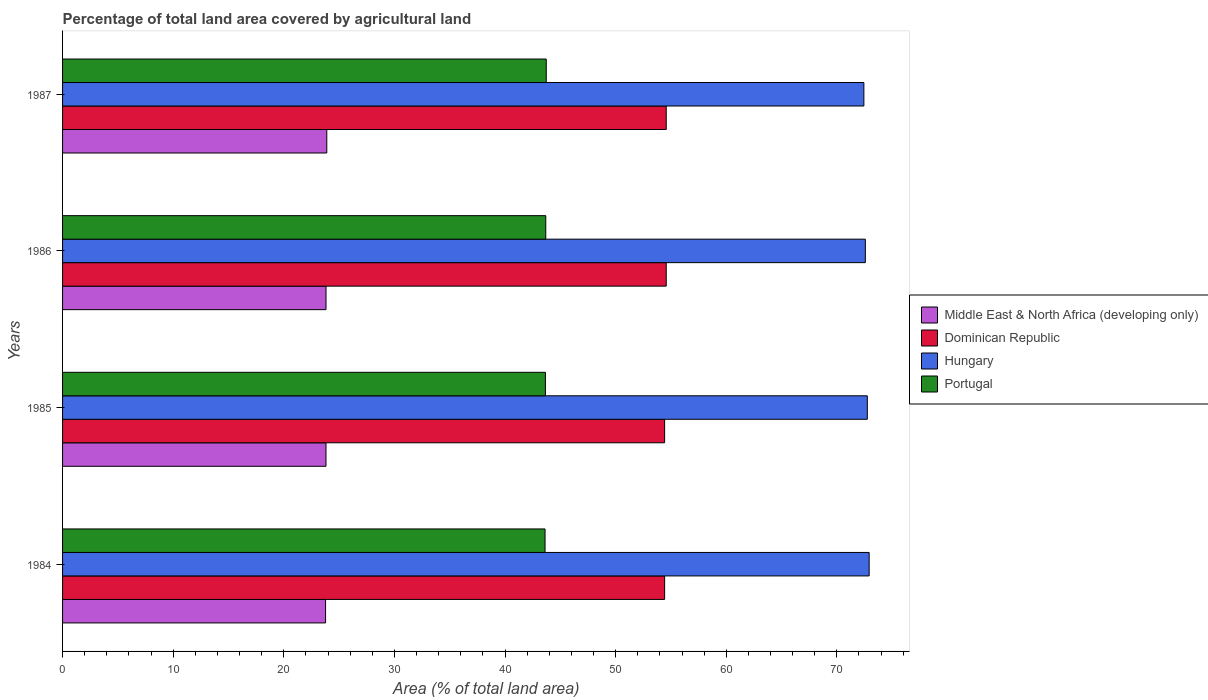How many different coloured bars are there?
Provide a short and direct response. 4. How many groups of bars are there?
Offer a terse response. 4. Are the number of bars on each tick of the Y-axis equal?
Give a very brief answer. Yes. What is the label of the 3rd group of bars from the top?
Provide a short and direct response. 1985. What is the percentage of agricultural land in Portugal in 1986?
Make the answer very short. 43.68. Across all years, what is the maximum percentage of agricultural land in Dominican Republic?
Ensure brevity in your answer.  54.57. Across all years, what is the minimum percentage of agricultural land in Hungary?
Keep it short and to the point. 72.44. What is the total percentage of agricultural land in Hungary in the graph?
Offer a terse response. 290.69. What is the difference between the percentage of agricultural land in Portugal in 1984 and that in 1985?
Provide a short and direct response. -0.03. What is the difference between the percentage of agricultural land in Dominican Republic in 1987 and the percentage of agricultural land in Portugal in 1985?
Your answer should be compact. 10.92. What is the average percentage of agricultural land in Dominican Republic per year?
Your answer should be very brief. 54.5. In the year 1984, what is the difference between the percentage of agricultural land in Portugal and percentage of agricultural land in Hungary?
Offer a very short reply. -29.3. What is the ratio of the percentage of agricultural land in Middle East & North Africa (developing only) in 1984 to that in 1986?
Give a very brief answer. 1. What is the difference between the highest and the second highest percentage of agricultural land in Middle East & North Africa (developing only)?
Give a very brief answer. 0.07. What is the difference between the highest and the lowest percentage of agricultural land in Middle East & North Africa (developing only)?
Your answer should be compact. 0.11. Is the sum of the percentage of agricultural land in Middle East & North Africa (developing only) in 1986 and 1987 greater than the maximum percentage of agricultural land in Hungary across all years?
Keep it short and to the point. No. How many bars are there?
Keep it short and to the point. 16. Are all the bars in the graph horizontal?
Give a very brief answer. Yes. How many years are there in the graph?
Ensure brevity in your answer.  4. What is the difference between two consecutive major ticks on the X-axis?
Ensure brevity in your answer.  10. Does the graph contain grids?
Offer a terse response. No. How are the legend labels stacked?
Keep it short and to the point. Vertical. What is the title of the graph?
Offer a very short reply. Percentage of total land area covered by agricultural land. What is the label or title of the X-axis?
Provide a succinct answer. Area (% of total land area). What is the Area (% of total land area) in Middle East & North Africa (developing only) in 1984?
Make the answer very short. 23.78. What is the Area (% of total land area) of Dominican Republic in 1984?
Provide a short and direct response. 54.43. What is the Area (% of total land area) of Hungary in 1984?
Offer a terse response. 72.92. What is the Area (% of total land area) of Portugal in 1984?
Make the answer very short. 43.62. What is the Area (% of total land area) in Middle East & North Africa (developing only) in 1985?
Offer a very short reply. 23.81. What is the Area (% of total land area) of Dominican Republic in 1985?
Offer a very short reply. 54.43. What is the Area (% of total land area) of Hungary in 1985?
Provide a succinct answer. 72.75. What is the Area (% of total land area) in Portugal in 1985?
Your response must be concise. 43.65. What is the Area (% of total land area) in Middle East & North Africa (developing only) in 1986?
Make the answer very short. 23.82. What is the Area (% of total land area) of Dominican Republic in 1986?
Keep it short and to the point. 54.57. What is the Area (% of total land area) in Hungary in 1986?
Offer a very short reply. 72.57. What is the Area (% of total land area) in Portugal in 1986?
Provide a short and direct response. 43.68. What is the Area (% of total land area) of Middle East & North Africa (developing only) in 1987?
Your response must be concise. 23.89. What is the Area (% of total land area) of Dominican Republic in 1987?
Provide a short and direct response. 54.57. What is the Area (% of total land area) in Hungary in 1987?
Provide a succinct answer. 72.44. What is the Area (% of total land area) of Portugal in 1987?
Ensure brevity in your answer.  43.73. Across all years, what is the maximum Area (% of total land area) of Middle East & North Africa (developing only)?
Keep it short and to the point. 23.89. Across all years, what is the maximum Area (% of total land area) in Dominican Republic?
Provide a short and direct response. 54.57. Across all years, what is the maximum Area (% of total land area) of Hungary?
Offer a very short reply. 72.92. Across all years, what is the maximum Area (% of total land area) of Portugal?
Your answer should be compact. 43.73. Across all years, what is the minimum Area (% of total land area) of Middle East & North Africa (developing only)?
Offer a terse response. 23.78. Across all years, what is the minimum Area (% of total land area) in Dominican Republic?
Offer a terse response. 54.43. Across all years, what is the minimum Area (% of total land area) in Hungary?
Make the answer very short. 72.44. Across all years, what is the minimum Area (% of total land area) in Portugal?
Your answer should be very brief. 43.62. What is the total Area (% of total land area) of Middle East & North Africa (developing only) in the graph?
Make the answer very short. 95.3. What is the total Area (% of total land area) in Dominican Republic in the graph?
Your answer should be very brief. 218. What is the total Area (% of total land area) in Hungary in the graph?
Give a very brief answer. 290.69. What is the total Area (% of total land area) of Portugal in the graph?
Ensure brevity in your answer.  174.68. What is the difference between the Area (% of total land area) in Middle East & North Africa (developing only) in 1984 and that in 1985?
Keep it short and to the point. -0.04. What is the difference between the Area (% of total land area) in Dominican Republic in 1984 and that in 1985?
Your answer should be very brief. 0. What is the difference between the Area (% of total land area) of Hungary in 1984 and that in 1985?
Give a very brief answer. 0.17. What is the difference between the Area (% of total land area) in Portugal in 1984 and that in 1985?
Provide a succinct answer. -0.03. What is the difference between the Area (% of total land area) in Middle East & North Africa (developing only) in 1984 and that in 1986?
Your answer should be very brief. -0.04. What is the difference between the Area (% of total land area) of Dominican Republic in 1984 and that in 1986?
Offer a terse response. -0.14. What is the difference between the Area (% of total land area) of Hungary in 1984 and that in 1986?
Your response must be concise. 0.34. What is the difference between the Area (% of total land area) in Portugal in 1984 and that in 1986?
Keep it short and to the point. -0.07. What is the difference between the Area (% of total land area) of Middle East & North Africa (developing only) in 1984 and that in 1987?
Provide a short and direct response. -0.11. What is the difference between the Area (% of total land area) in Dominican Republic in 1984 and that in 1987?
Ensure brevity in your answer.  -0.14. What is the difference between the Area (% of total land area) in Hungary in 1984 and that in 1987?
Provide a short and direct response. 0.48. What is the difference between the Area (% of total land area) in Portugal in 1984 and that in 1987?
Offer a very short reply. -0.11. What is the difference between the Area (% of total land area) in Middle East & North Africa (developing only) in 1985 and that in 1986?
Your response must be concise. -0. What is the difference between the Area (% of total land area) of Dominican Republic in 1985 and that in 1986?
Your answer should be compact. -0.14. What is the difference between the Area (% of total land area) in Hungary in 1985 and that in 1986?
Provide a succinct answer. 0.18. What is the difference between the Area (% of total land area) of Portugal in 1985 and that in 1986?
Make the answer very short. -0.03. What is the difference between the Area (% of total land area) of Middle East & North Africa (developing only) in 1985 and that in 1987?
Your response must be concise. -0.07. What is the difference between the Area (% of total land area) of Dominican Republic in 1985 and that in 1987?
Your response must be concise. -0.14. What is the difference between the Area (% of total land area) in Hungary in 1985 and that in 1987?
Provide a succinct answer. 0.31. What is the difference between the Area (% of total land area) in Portugal in 1985 and that in 1987?
Keep it short and to the point. -0.08. What is the difference between the Area (% of total land area) of Middle East & North Africa (developing only) in 1986 and that in 1987?
Provide a short and direct response. -0.07. What is the difference between the Area (% of total land area) of Dominican Republic in 1986 and that in 1987?
Ensure brevity in your answer.  0. What is the difference between the Area (% of total land area) in Hungary in 1986 and that in 1987?
Offer a very short reply. 0.13. What is the difference between the Area (% of total land area) of Portugal in 1986 and that in 1987?
Your response must be concise. -0.04. What is the difference between the Area (% of total land area) in Middle East & North Africa (developing only) in 1984 and the Area (% of total land area) in Dominican Republic in 1985?
Ensure brevity in your answer.  -30.65. What is the difference between the Area (% of total land area) in Middle East & North Africa (developing only) in 1984 and the Area (% of total land area) in Hungary in 1985?
Your response must be concise. -48.98. What is the difference between the Area (% of total land area) in Middle East & North Africa (developing only) in 1984 and the Area (% of total land area) in Portugal in 1985?
Offer a very short reply. -19.87. What is the difference between the Area (% of total land area) of Dominican Republic in 1984 and the Area (% of total land area) of Hungary in 1985?
Provide a succinct answer. -18.32. What is the difference between the Area (% of total land area) in Dominican Republic in 1984 and the Area (% of total land area) in Portugal in 1985?
Offer a terse response. 10.78. What is the difference between the Area (% of total land area) in Hungary in 1984 and the Area (% of total land area) in Portugal in 1985?
Keep it short and to the point. 29.27. What is the difference between the Area (% of total land area) in Middle East & North Africa (developing only) in 1984 and the Area (% of total land area) in Dominican Republic in 1986?
Keep it short and to the point. -30.8. What is the difference between the Area (% of total land area) of Middle East & North Africa (developing only) in 1984 and the Area (% of total land area) of Hungary in 1986?
Give a very brief answer. -48.8. What is the difference between the Area (% of total land area) of Middle East & North Africa (developing only) in 1984 and the Area (% of total land area) of Portugal in 1986?
Offer a terse response. -19.91. What is the difference between the Area (% of total land area) in Dominican Republic in 1984 and the Area (% of total land area) in Hungary in 1986?
Provide a short and direct response. -18.15. What is the difference between the Area (% of total land area) in Dominican Republic in 1984 and the Area (% of total land area) in Portugal in 1986?
Ensure brevity in your answer.  10.75. What is the difference between the Area (% of total land area) of Hungary in 1984 and the Area (% of total land area) of Portugal in 1986?
Your answer should be very brief. 29.24. What is the difference between the Area (% of total land area) of Middle East & North Africa (developing only) in 1984 and the Area (% of total land area) of Dominican Republic in 1987?
Ensure brevity in your answer.  -30.8. What is the difference between the Area (% of total land area) of Middle East & North Africa (developing only) in 1984 and the Area (% of total land area) of Hungary in 1987?
Keep it short and to the point. -48.66. What is the difference between the Area (% of total land area) of Middle East & North Africa (developing only) in 1984 and the Area (% of total land area) of Portugal in 1987?
Offer a very short reply. -19.95. What is the difference between the Area (% of total land area) of Dominican Republic in 1984 and the Area (% of total land area) of Hungary in 1987?
Your answer should be very brief. -18.01. What is the difference between the Area (% of total land area) in Dominican Republic in 1984 and the Area (% of total land area) in Portugal in 1987?
Keep it short and to the point. 10.7. What is the difference between the Area (% of total land area) of Hungary in 1984 and the Area (% of total land area) of Portugal in 1987?
Keep it short and to the point. 29.19. What is the difference between the Area (% of total land area) in Middle East & North Africa (developing only) in 1985 and the Area (% of total land area) in Dominican Republic in 1986?
Offer a very short reply. -30.76. What is the difference between the Area (% of total land area) of Middle East & North Africa (developing only) in 1985 and the Area (% of total land area) of Hungary in 1986?
Make the answer very short. -48.76. What is the difference between the Area (% of total land area) in Middle East & North Africa (developing only) in 1985 and the Area (% of total land area) in Portugal in 1986?
Keep it short and to the point. -19.87. What is the difference between the Area (% of total land area) in Dominican Republic in 1985 and the Area (% of total land area) in Hungary in 1986?
Your answer should be very brief. -18.15. What is the difference between the Area (% of total land area) in Dominican Republic in 1985 and the Area (% of total land area) in Portugal in 1986?
Provide a short and direct response. 10.75. What is the difference between the Area (% of total land area) in Hungary in 1985 and the Area (% of total land area) in Portugal in 1986?
Your answer should be very brief. 29.07. What is the difference between the Area (% of total land area) in Middle East & North Africa (developing only) in 1985 and the Area (% of total land area) in Dominican Republic in 1987?
Provide a succinct answer. -30.76. What is the difference between the Area (% of total land area) in Middle East & North Africa (developing only) in 1985 and the Area (% of total land area) in Hungary in 1987?
Offer a terse response. -48.63. What is the difference between the Area (% of total land area) of Middle East & North Africa (developing only) in 1985 and the Area (% of total land area) of Portugal in 1987?
Keep it short and to the point. -19.91. What is the difference between the Area (% of total land area) of Dominican Republic in 1985 and the Area (% of total land area) of Hungary in 1987?
Offer a very short reply. -18.01. What is the difference between the Area (% of total land area) in Dominican Republic in 1985 and the Area (% of total land area) in Portugal in 1987?
Provide a short and direct response. 10.7. What is the difference between the Area (% of total land area) of Hungary in 1985 and the Area (% of total land area) of Portugal in 1987?
Ensure brevity in your answer.  29.03. What is the difference between the Area (% of total land area) of Middle East & North Africa (developing only) in 1986 and the Area (% of total land area) of Dominican Republic in 1987?
Ensure brevity in your answer.  -30.76. What is the difference between the Area (% of total land area) of Middle East & North Africa (developing only) in 1986 and the Area (% of total land area) of Hungary in 1987?
Offer a very short reply. -48.62. What is the difference between the Area (% of total land area) in Middle East & North Africa (developing only) in 1986 and the Area (% of total land area) in Portugal in 1987?
Your answer should be compact. -19.91. What is the difference between the Area (% of total land area) of Dominican Republic in 1986 and the Area (% of total land area) of Hungary in 1987?
Offer a terse response. -17.87. What is the difference between the Area (% of total land area) in Dominican Republic in 1986 and the Area (% of total land area) in Portugal in 1987?
Your answer should be compact. 10.85. What is the difference between the Area (% of total land area) in Hungary in 1986 and the Area (% of total land area) in Portugal in 1987?
Ensure brevity in your answer.  28.85. What is the average Area (% of total land area) in Middle East & North Africa (developing only) per year?
Your response must be concise. 23.82. What is the average Area (% of total land area) in Dominican Republic per year?
Provide a short and direct response. 54.5. What is the average Area (% of total land area) in Hungary per year?
Ensure brevity in your answer.  72.67. What is the average Area (% of total land area) of Portugal per year?
Provide a succinct answer. 43.67. In the year 1984, what is the difference between the Area (% of total land area) in Middle East & North Africa (developing only) and Area (% of total land area) in Dominican Republic?
Your answer should be very brief. -30.65. In the year 1984, what is the difference between the Area (% of total land area) of Middle East & North Africa (developing only) and Area (% of total land area) of Hungary?
Keep it short and to the point. -49.14. In the year 1984, what is the difference between the Area (% of total land area) in Middle East & North Africa (developing only) and Area (% of total land area) in Portugal?
Provide a succinct answer. -19.84. In the year 1984, what is the difference between the Area (% of total land area) in Dominican Republic and Area (% of total land area) in Hungary?
Provide a succinct answer. -18.49. In the year 1984, what is the difference between the Area (% of total land area) in Dominican Republic and Area (% of total land area) in Portugal?
Provide a succinct answer. 10.81. In the year 1984, what is the difference between the Area (% of total land area) of Hungary and Area (% of total land area) of Portugal?
Ensure brevity in your answer.  29.3. In the year 1985, what is the difference between the Area (% of total land area) in Middle East & North Africa (developing only) and Area (% of total land area) in Dominican Republic?
Offer a very short reply. -30.61. In the year 1985, what is the difference between the Area (% of total land area) of Middle East & North Africa (developing only) and Area (% of total land area) of Hungary?
Make the answer very short. -48.94. In the year 1985, what is the difference between the Area (% of total land area) in Middle East & North Africa (developing only) and Area (% of total land area) in Portugal?
Offer a terse response. -19.84. In the year 1985, what is the difference between the Area (% of total land area) in Dominican Republic and Area (% of total land area) in Hungary?
Offer a terse response. -18.32. In the year 1985, what is the difference between the Area (% of total land area) of Dominican Republic and Area (% of total land area) of Portugal?
Make the answer very short. 10.78. In the year 1985, what is the difference between the Area (% of total land area) in Hungary and Area (% of total land area) in Portugal?
Keep it short and to the point. 29.1. In the year 1986, what is the difference between the Area (% of total land area) of Middle East & North Africa (developing only) and Area (% of total land area) of Dominican Republic?
Your answer should be very brief. -30.76. In the year 1986, what is the difference between the Area (% of total land area) in Middle East & North Africa (developing only) and Area (% of total land area) in Hungary?
Keep it short and to the point. -48.76. In the year 1986, what is the difference between the Area (% of total land area) of Middle East & North Africa (developing only) and Area (% of total land area) of Portugal?
Your answer should be compact. -19.87. In the year 1986, what is the difference between the Area (% of total land area) of Dominican Republic and Area (% of total land area) of Hungary?
Make the answer very short. -18. In the year 1986, what is the difference between the Area (% of total land area) of Dominican Republic and Area (% of total land area) of Portugal?
Offer a very short reply. 10.89. In the year 1986, what is the difference between the Area (% of total land area) of Hungary and Area (% of total land area) of Portugal?
Give a very brief answer. 28.89. In the year 1987, what is the difference between the Area (% of total land area) in Middle East & North Africa (developing only) and Area (% of total land area) in Dominican Republic?
Provide a short and direct response. -30.69. In the year 1987, what is the difference between the Area (% of total land area) in Middle East & North Africa (developing only) and Area (% of total land area) in Hungary?
Your response must be concise. -48.56. In the year 1987, what is the difference between the Area (% of total land area) of Middle East & North Africa (developing only) and Area (% of total land area) of Portugal?
Offer a terse response. -19.84. In the year 1987, what is the difference between the Area (% of total land area) of Dominican Republic and Area (% of total land area) of Hungary?
Offer a terse response. -17.87. In the year 1987, what is the difference between the Area (% of total land area) in Dominican Republic and Area (% of total land area) in Portugal?
Keep it short and to the point. 10.85. In the year 1987, what is the difference between the Area (% of total land area) in Hungary and Area (% of total land area) in Portugal?
Your answer should be very brief. 28.71. What is the ratio of the Area (% of total land area) of Portugal in 1984 to that in 1986?
Keep it short and to the point. 1. What is the ratio of the Area (% of total land area) in Middle East & North Africa (developing only) in 1984 to that in 1987?
Your answer should be compact. 1. What is the ratio of the Area (% of total land area) of Hungary in 1984 to that in 1987?
Provide a short and direct response. 1.01. What is the ratio of the Area (% of total land area) of Portugal in 1984 to that in 1987?
Ensure brevity in your answer.  1. What is the ratio of the Area (% of total land area) of Dominican Republic in 1985 to that in 1986?
Ensure brevity in your answer.  1. What is the ratio of the Area (% of total land area) in Portugal in 1985 to that in 1986?
Give a very brief answer. 1. What is the ratio of the Area (% of total land area) in Middle East & North Africa (developing only) in 1985 to that in 1987?
Your answer should be very brief. 1. What is the ratio of the Area (% of total land area) in Portugal in 1985 to that in 1987?
Your answer should be compact. 1. What is the ratio of the Area (% of total land area) of Hungary in 1986 to that in 1987?
Ensure brevity in your answer.  1. What is the ratio of the Area (% of total land area) of Portugal in 1986 to that in 1987?
Provide a short and direct response. 1. What is the difference between the highest and the second highest Area (% of total land area) of Middle East & North Africa (developing only)?
Ensure brevity in your answer.  0.07. What is the difference between the highest and the second highest Area (% of total land area) in Dominican Republic?
Ensure brevity in your answer.  0. What is the difference between the highest and the second highest Area (% of total land area) of Hungary?
Your answer should be compact. 0.17. What is the difference between the highest and the second highest Area (% of total land area) in Portugal?
Your response must be concise. 0.04. What is the difference between the highest and the lowest Area (% of total land area) of Middle East & North Africa (developing only)?
Ensure brevity in your answer.  0.11. What is the difference between the highest and the lowest Area (% of total land area) of Dominican Republic?
Keep it short and to the point. 0.14. What is the difference between the highest and the lowest Area (% of total land area) of Hungary?
Your response must be concise. 0.48. What is the difference between the highest and the lowest Area (% of total land area) in Portugal?
Give a very brief answer. 0.11. 